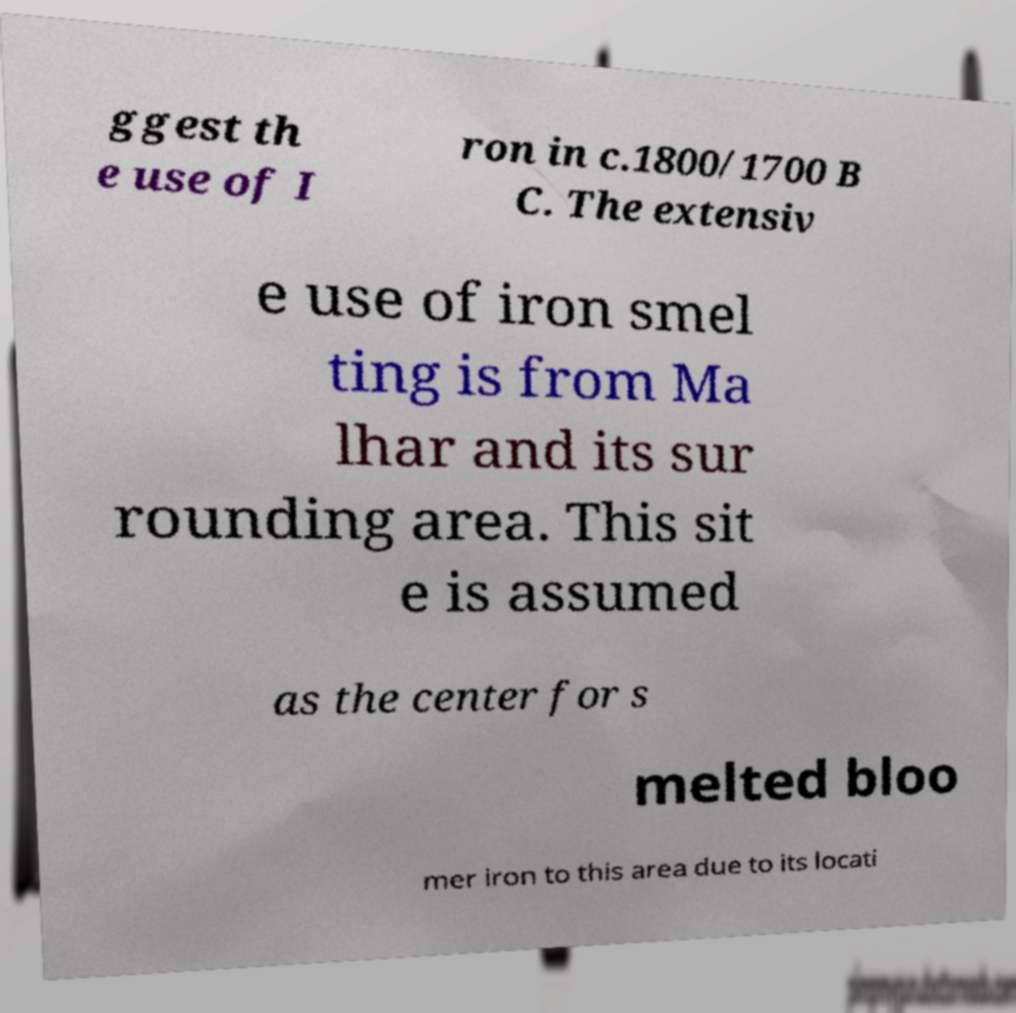For documentation purposes, I need the text within this image transcribed. Could you provide that? ggest th e use of I ron in c.1800/1700 B C. The extensiv e use of iron smel ting is from Ma lhar and its sur rounding area. This sit e is assumed as the center for s melted bloo mer iron to this area due to its locati 